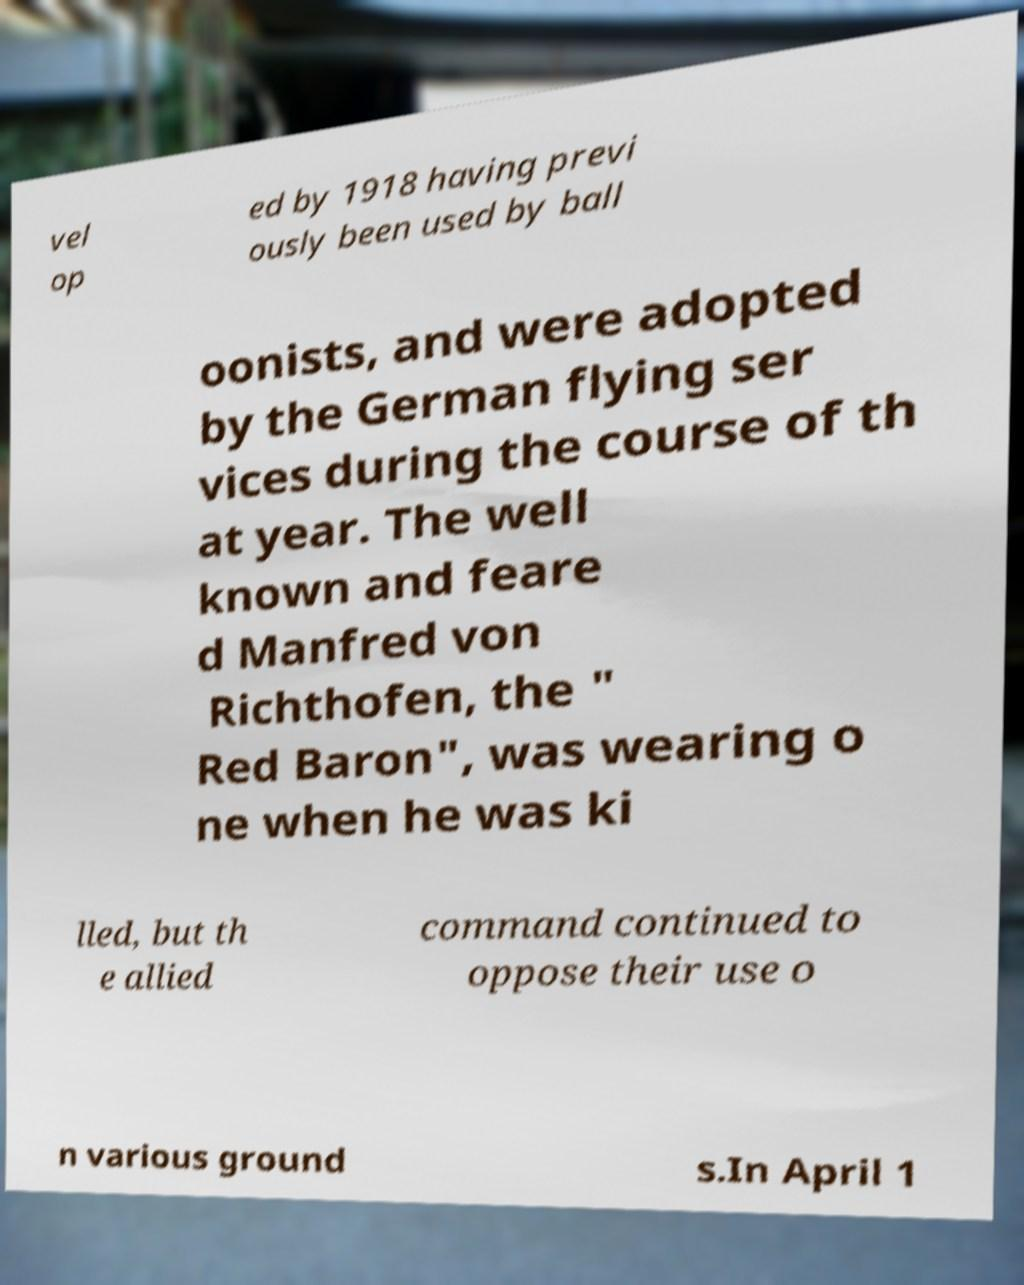Please identify and transcribe the text found in this image. vel op ed by 1918 having previ ously been used by ball oonists, and were adopted by the German flying ser vices during the course of th at year. The well known and feare d Manfred von Richthofen, the " Red Baron", was wearing o ne when he was ki lled, but th e allied command continued to oppose their use o n various ground s.In April 1 